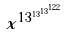Convert formula to latex. <formula><loc_0><loc_0><loc_500><loc_500>x ^ { 1 3 ^ { 1 3 ^ { 1 3 ^ { 1 2 2 } } } }</formula> 